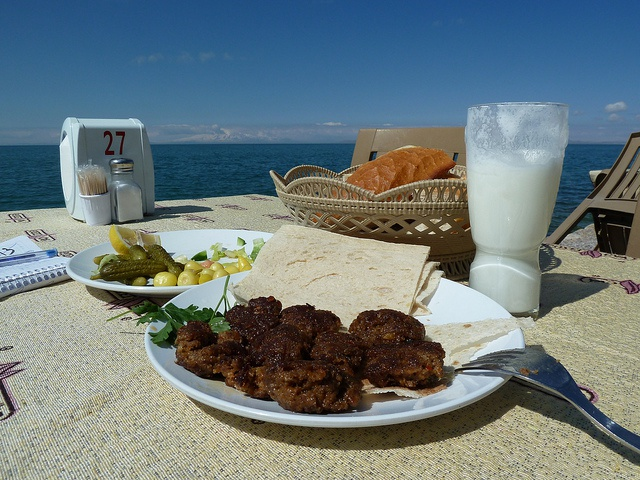Describe the objects in this image and their specific colors. I can see dining table in blue, darkgray, black, beige, and lightgray tones, cup in blue, darkgray, lightgray, and gray tones, bowl in blue, olive, black, and gray tones, chair in blue, gray, and black tones, and fork in blue, gray, navy, and black tones in this image. 